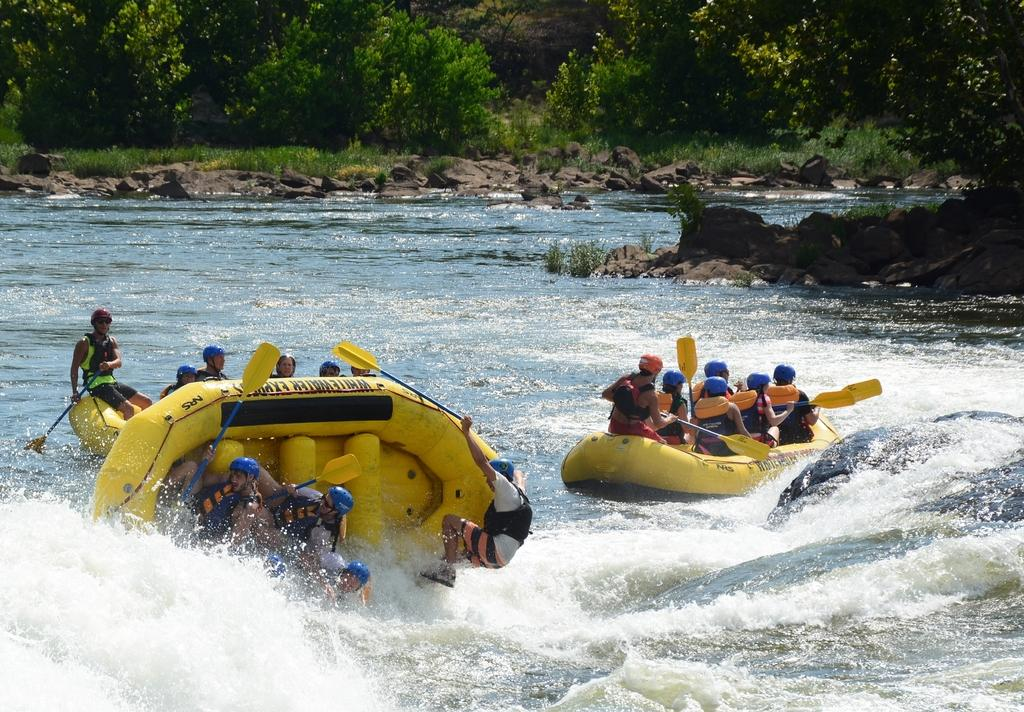What activity are the people in the image participating in? The people in the image are rafting. Where are the people located in the image? The people are on the water. What can be seen in the background of the image? There are trees and rocks in the background of the image. What type of bike is being used by the people in the image? There is no bike present in the image; the people are rafting on the water. 